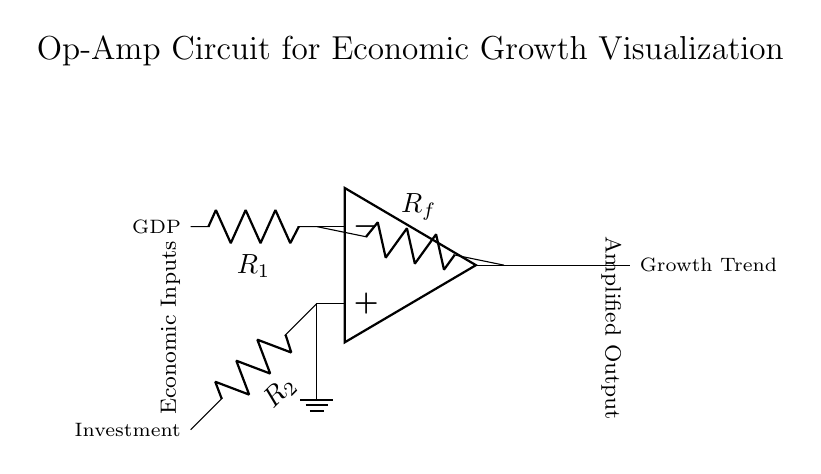What is the purpose of the operational amplifier in this circuit? The operational amplifier increases the signal from the input resistors, providing a gain that represents the relationship between GDP and Investment, ultimately visualizing economic growth trends.
Answer: amplification What are the inputs to the operational amplifier? The circuit has two inputs: one connected to GDP through resistor R1 and the other to Investment through resistor R2.
Answer: GDP and Investment What does the output of the operational amplifier represent? The output signifies the amplified result of the input signals, which in this context is interpreted as the Growth Trend in economic terms.
Answer: Growth Trend What is the role of the feedback resistor in this circuit? The feedback resistor Rf controls the gain of the operational amplifier, affecting how much of the output signal is fed back to the input, thus stabilizing the operation and shaping the response based on the economic inputs.
Answer: gain control How does the grounding of the non-inverting input affect the circuit? Grounding the non-inverting input establishes a reference point of zero voltage, ensuring that the output is influenced only by the inverting input (connected to GDP) alongside the investment input, optimizing the operational characteristics of the amplifier.
Answer: zero reference 